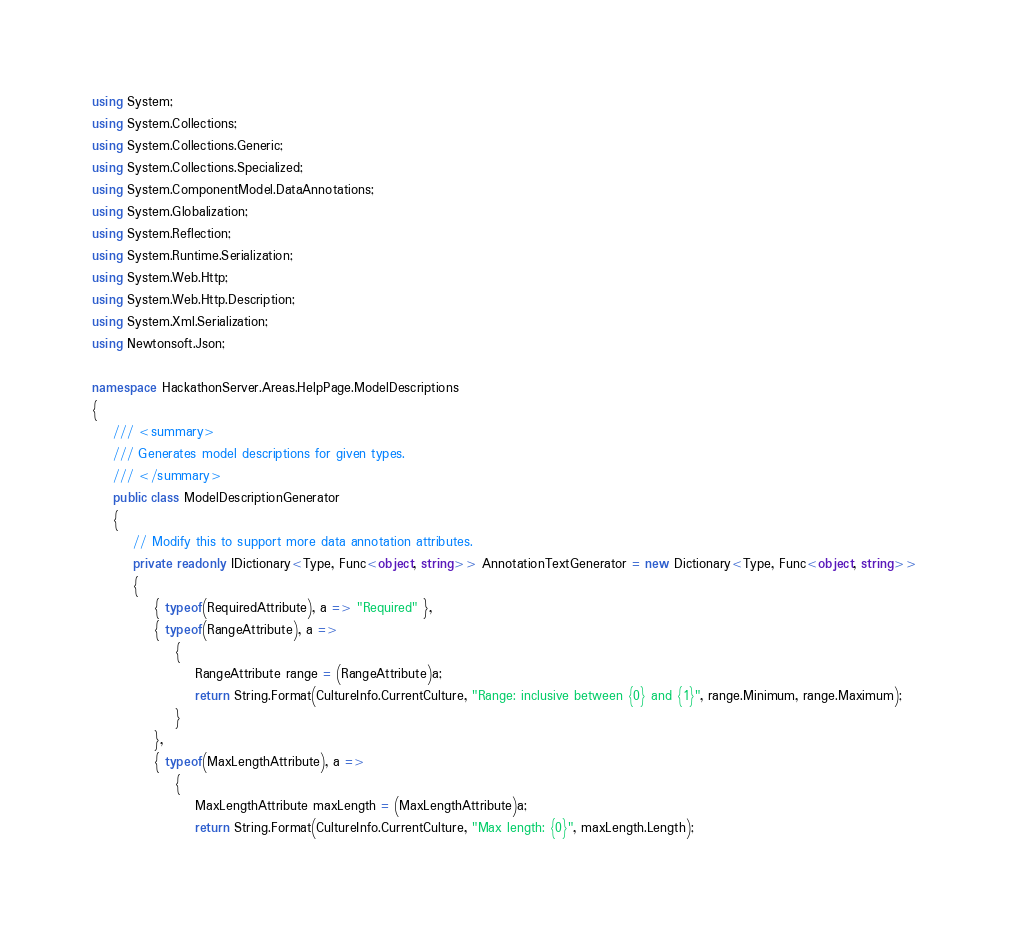<code> <loc_0><loc_0><loc_500><loc_500><_C#_>using System;
using System.Collections;
using System.Collections.Generic;
using System.Collections.Specialized;
using System.ComponentModel.DataAnnotations;
using System.Globalization;
using System.Reflection;
using System.Runtime.Serialization;
using System.Web.Http;
using System.Web.Http.Description;
using System.Xml.Serialization;
using Newtonsoft.Json;

namespace HackathonServer.Areas.HelpPage.ModelDescriptions
{
    /// <summary>
    /// Generates model descriptions for given types.
    /// </summary>
    public class ModelDescriptionGenerator
    {
        // Modify this to support more data annotation attributes.
        private readonly IDictionary<Type, Func<object, string>> AnnotationTextGenerator = new Dictionary<Type, Func<object, string>>
        {
            { typeof(RequiredAttribute), a => "Required" },
            { typeof(RangeAttribute), a =>
                {
                    RangeAttribute range = (RangeAttribute)a;
                    return String.Format(CultureInfo.CurrentCulture, "Range: inclusive between {0} and {1}", range.Minimum, range.Maximum);
                }
            },
            { typeof(MaxLengthAttribute), a =>
                {
                    MaxLengthAttribute maxLength = (MaxLengthAttribute)a;
                    return String.Format(CultureInfo.CurrentCulture, "Max length: {0}", maxLength.Length);</code> 